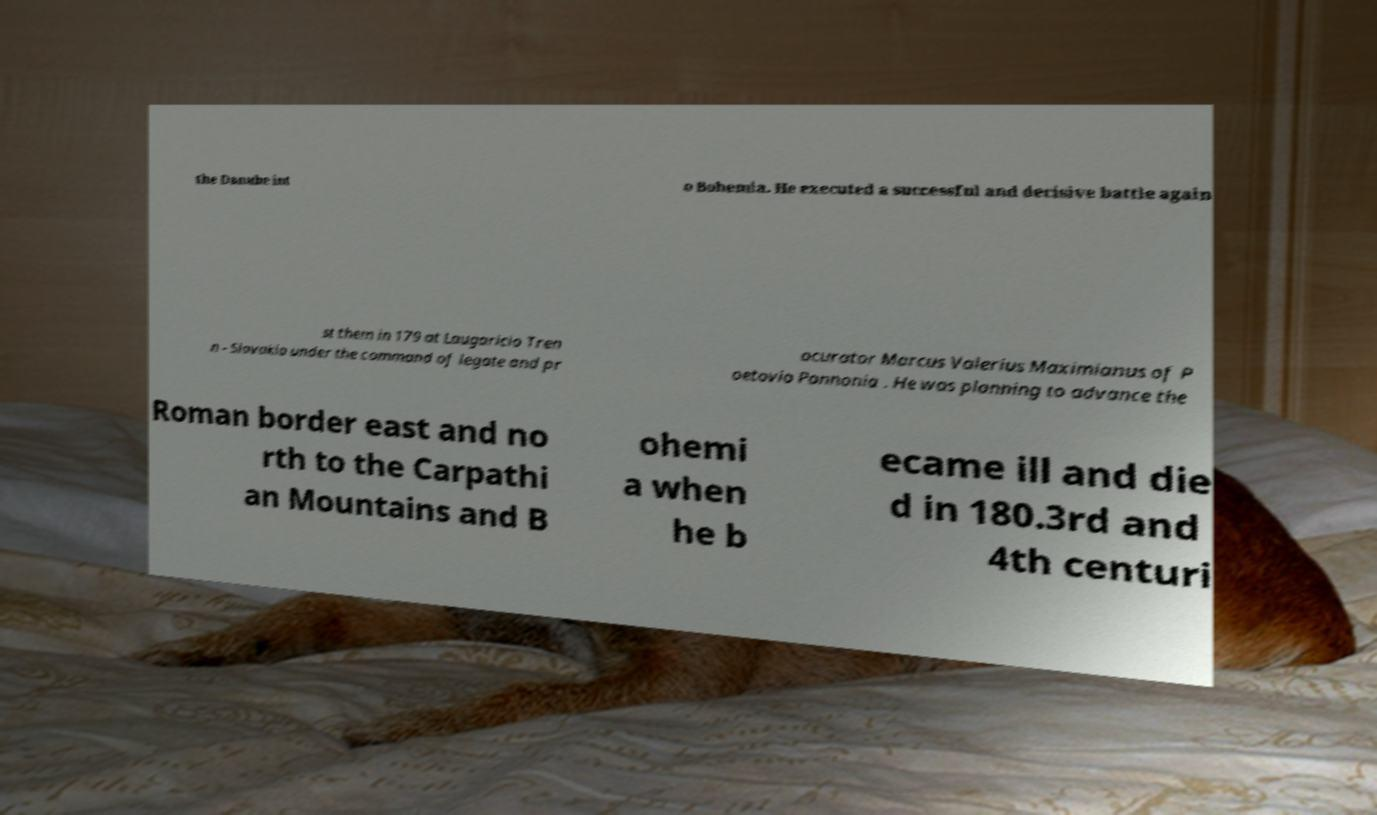Could you extract and type out the text from this image? the Danube int o Bohemia. He executed a successful and decisive battle again st them in 179 at Laugaricio Tren n - Slovakia under the command of legate and pr ocurator Marcus Valerius Maximianus of P oetovio Pannonia . He was planning to advance the Roman border east and no rth to the Carpathi an Mountains and B ohemi a when he b ecame ill and die d in 180.3rd and 4th centuri 